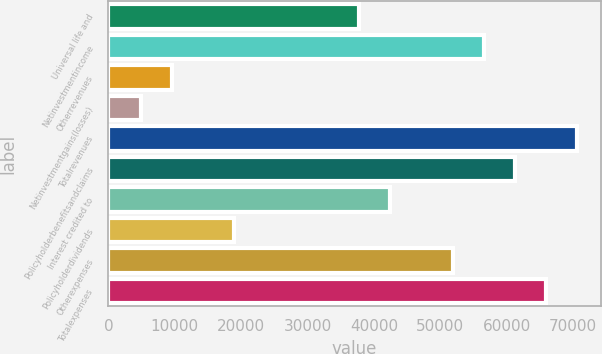Convert chart to OTSL. <chart><loc_0><loc_0><loc_500><loc_500><bar_chart><fcel>Universal life and<fcel>Netinvestmentincome<fcel>Otherrevenues<fcel>Netinvestmentgains(losses)<fcel>Totalrevenues<fcel>Policyholderbenefitsandclaims<fcel>Interest credited to<fcel>Policyholderdividends<fcel>Otherexpenses<fcel>Totalexpenses<nl><fcel>37769.4<fcel>56546.6<fcel>9603.6<fcel>4909.3<fcel>70629.5<fcel>61240.9<fcel>42463.7<fcel>18992.2<fcel>51852.3<fcel>65935.2<nl></chart> 